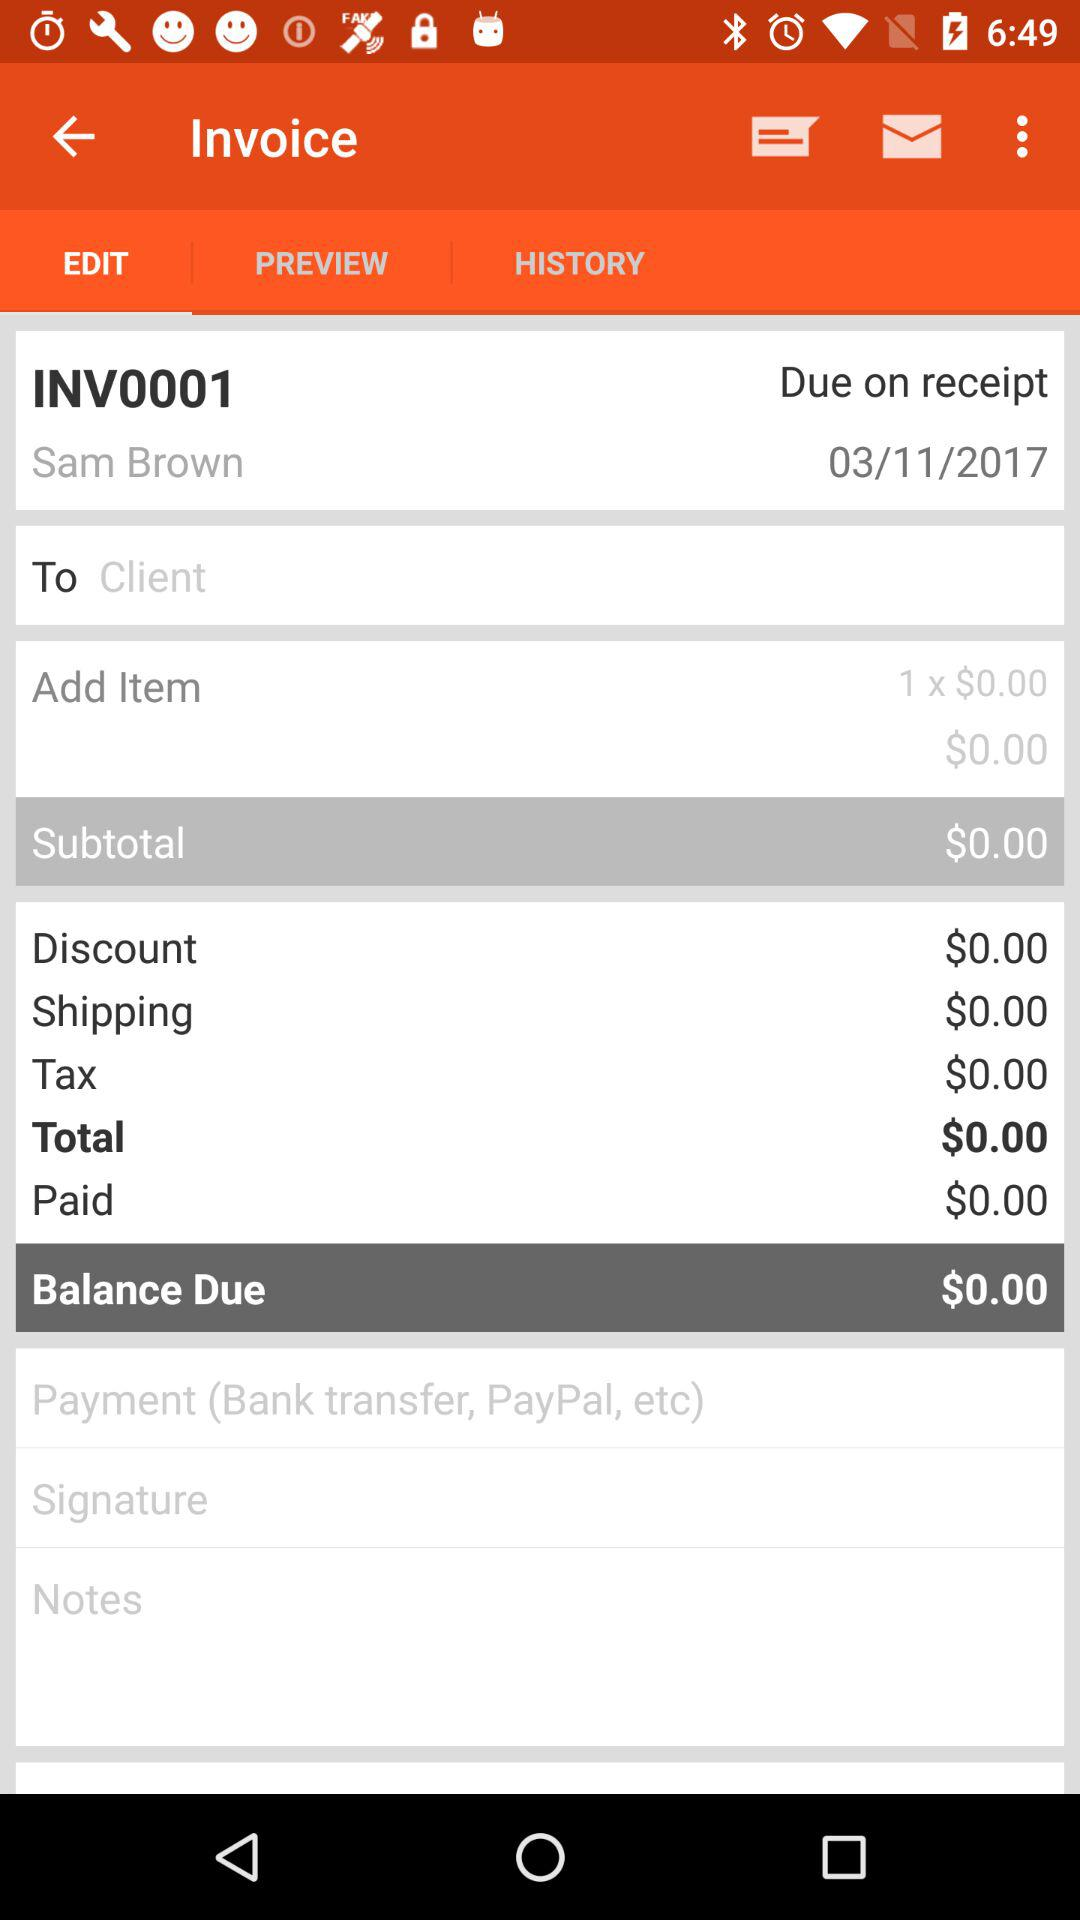When was the last transaction made?
When the provided information is insufficient, respond with <no answer>. <no answer> 